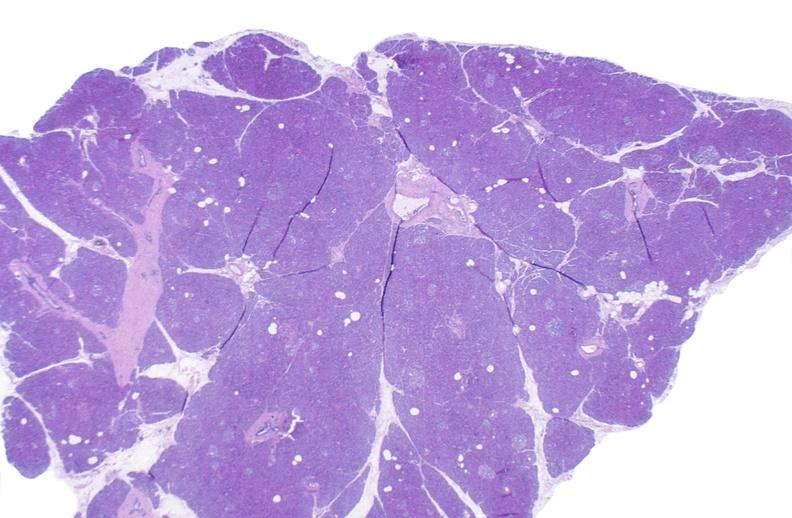does this image show normal pancreas?
Answer the question using a single word or phrase. Yes 